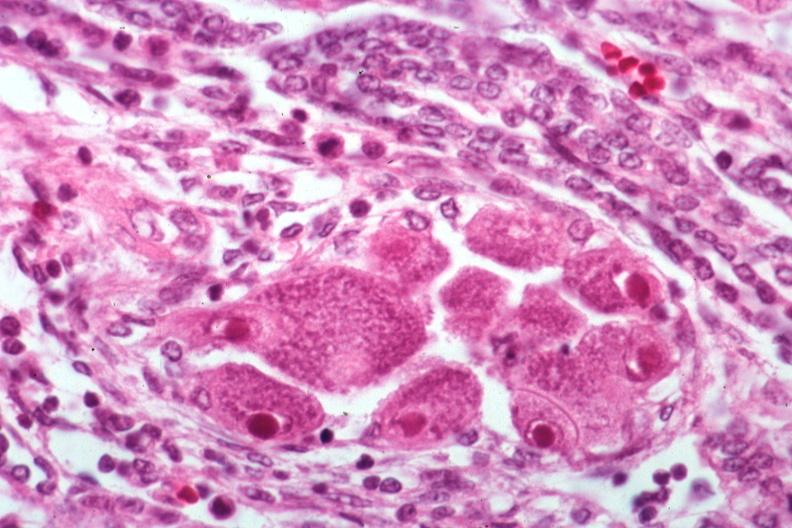what is present?
Answer the question using a single word or phrase. Kidney 